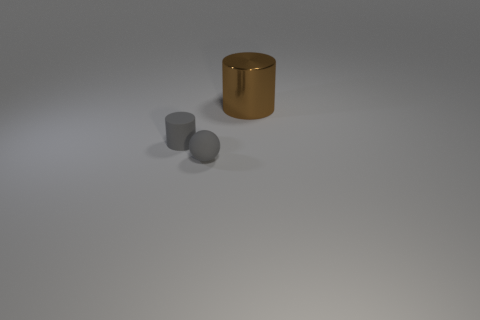Add 1 small matte spheres. How many objects exist? 4 Subtract all spheres. How many objects are left? 2 Subtract 0 cyan cylinders. How many objects are left? 3 Subtract all tiny red shiny cubes. Subtract all cylinders. How many objects are left? 1 Add 3 rubber balls. How many rubber balls are left? 4 Add 1 large rubber blocks. How many large rubber blocks exist? 1 